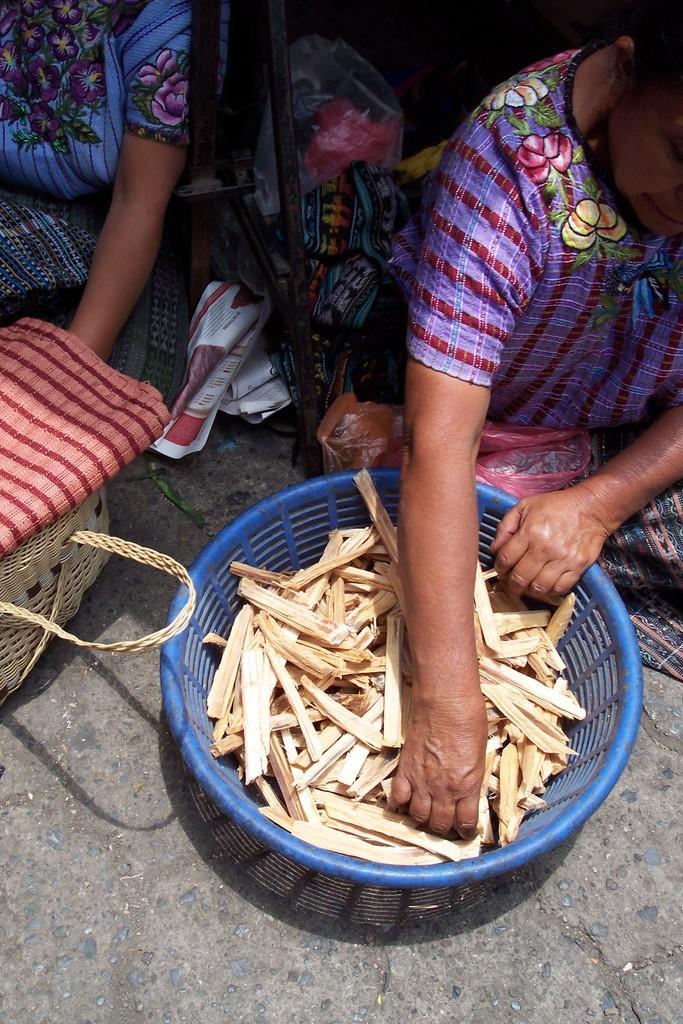How would you summarize this image in a sentence or two? In this image we can see ladies sitting on the floor. There is a basket with some item. Also there is another basket. On the top of the basket there is another object. And there are plastic covers, papers and stand. 